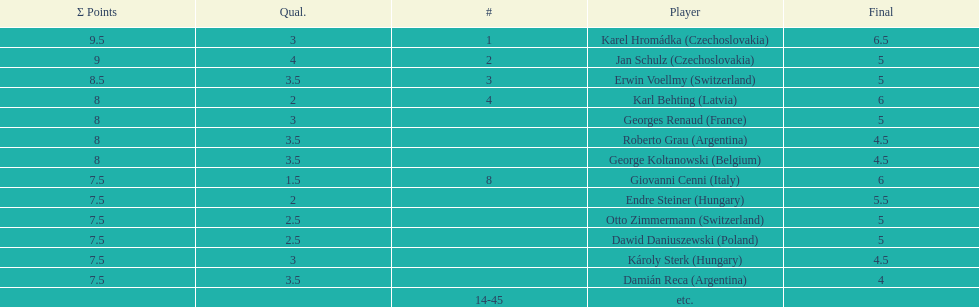Did the two competitors from hungary get more or less combined points than the two competitors from argentina? Less. 